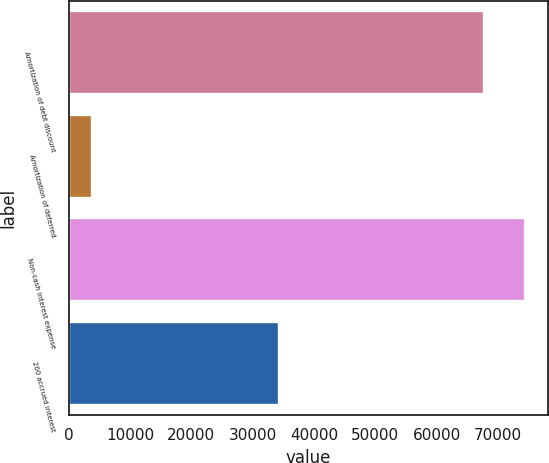Convert chart to OTSL. <chart><loc_0><loc_0><loc_500><loc_500><bar_chart><fcel>Amortization of debt discount<fcel>Amortization of deferred<fcel>Non-cash interest expense<fcel>200 accrued interest<nl><fcel>67673<fcel>3786<fcel>74440.3<fcel>34269<nl></chart> 